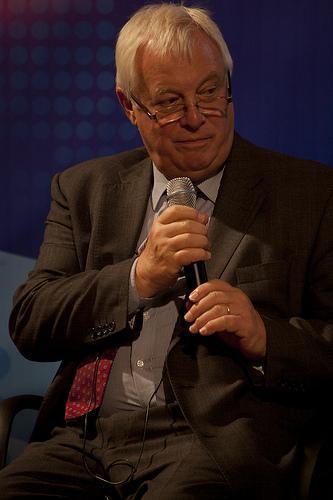How many people in picture?
Give a very brief answer. 1. 